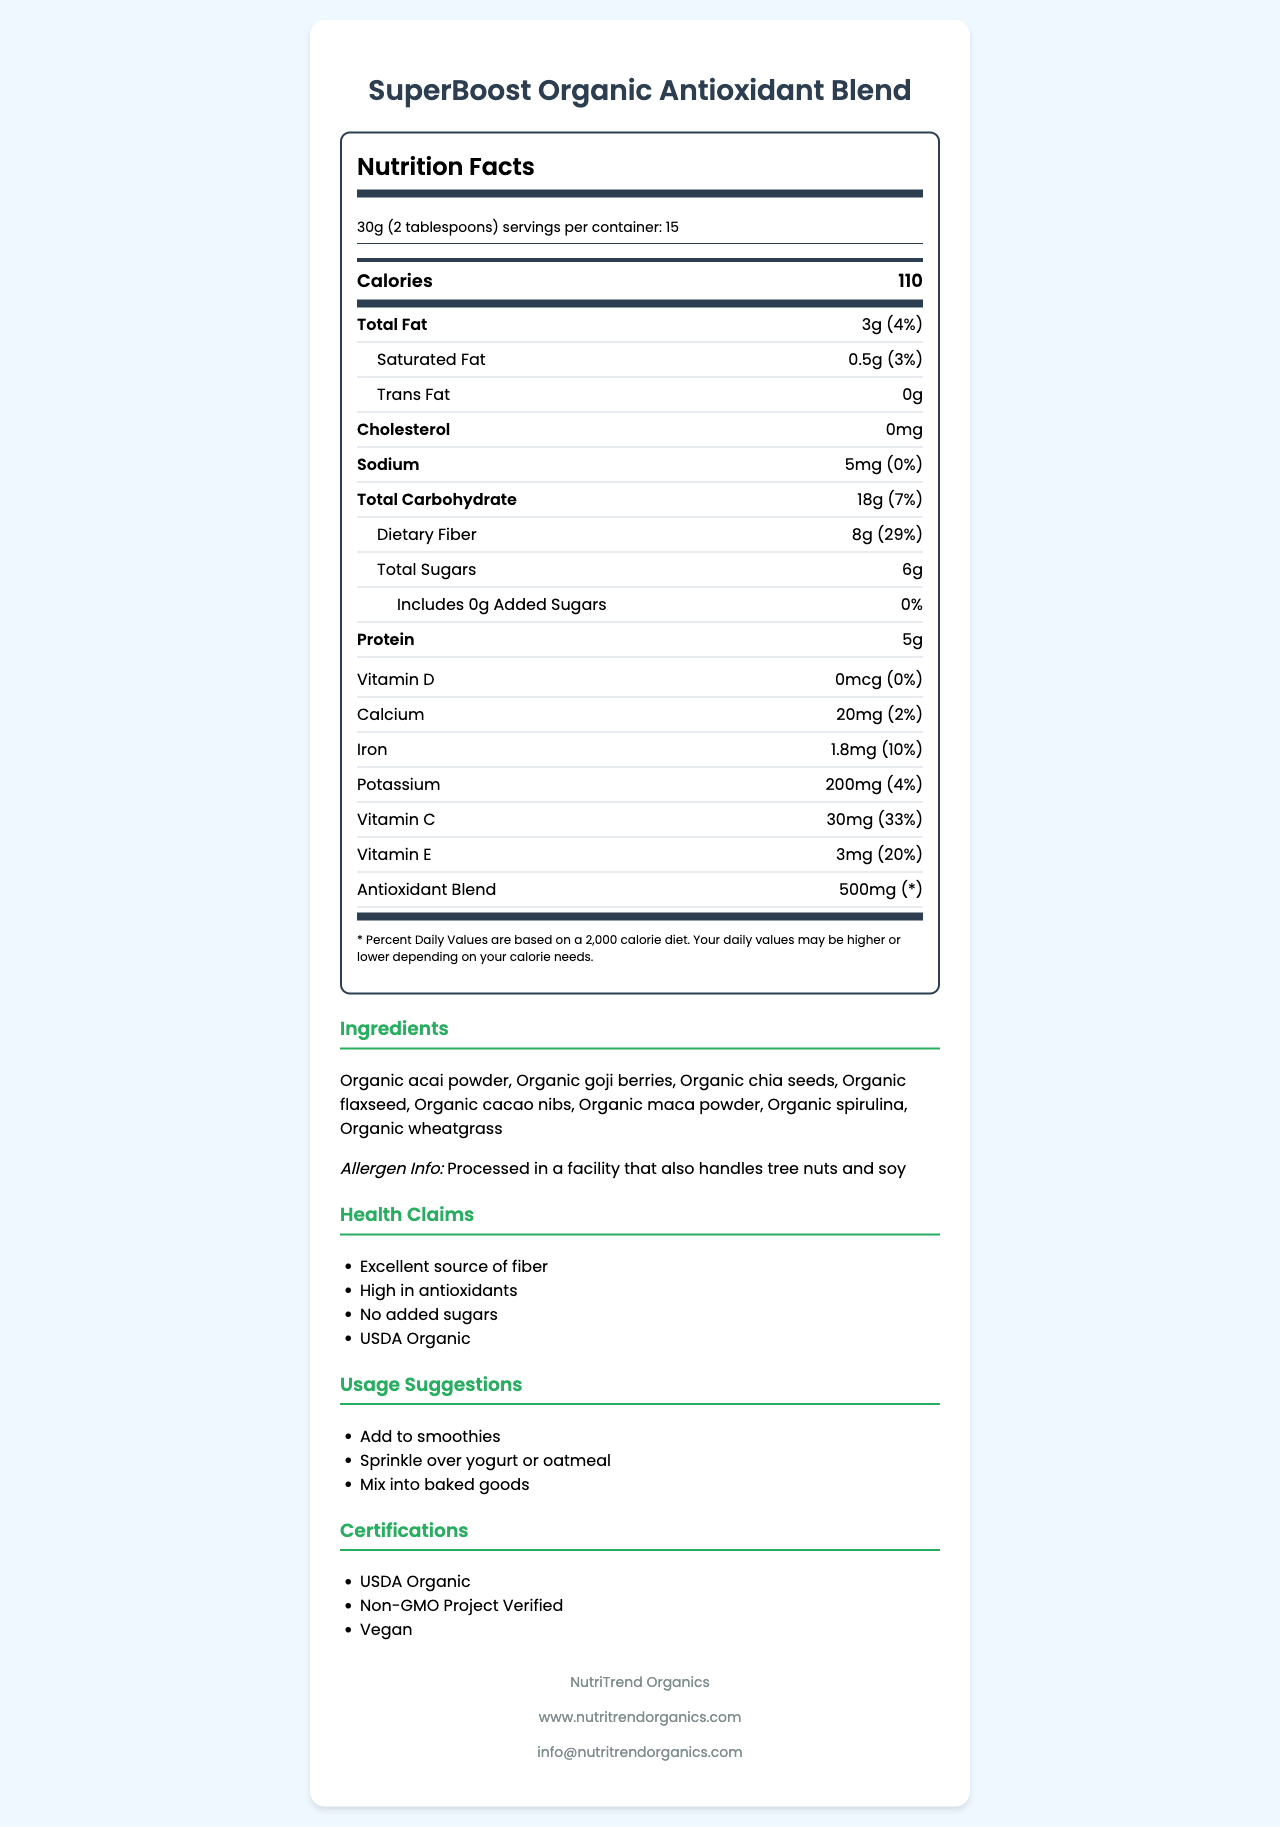what is the serving size? The document specifies the serving size right at the top under "serving info."
Answer: 30g (2 tablespoons) how many calories are in a serving? The document lists the calories as a prominent number in the "large-nutrients" section.
Answer: 110 how much dietary fiber does one serving contain? The amount is listed under "Total Carbohydrate" with an indented label "Dietary Fiber."
Answer: 8g what are the ingredients in this product? The "Ingredients" section lists all the components used in the product.
Answer: Organic acai powder, Organic goji berries, Organic chia seeds, Organic flaxseed, Organic cacao nibs, Organic maca powder, Organic spirulina, Organic wheatgrass how much protein is in one serving? The document lists protein in a dedicated row under the large nutrients.
Answer: 5g what is the suggested storage condition for this product? The "storage instructions" section provides the details for storing the product.
Answer: Store in a cool, dry place. Refrigerate after opening. what is the percentage of daily value for vitamin C? The percentage for vitamin C is listed in the "Vitamins" section of the document.
Answer: 33% how many servings are in one container? The "serving info" section states that there are 15 servings per container.
Answer: 15 what is the cholesterol content per serving? The document shows cholesterol content as 0mg under its own row.
Answer: 0mg does this product contain any added sugars? The document explicitly states "Includes 0g Added Sugars" with a daily value of 0%.
Answer: No which of the following is not an ingredient in this product? A. Organic acai powder B. Organic goji berries C. Organic honey D. Organic spirulina The ingredient list does not mention Organic honey, thus making C the correct answer.
Answer: C what health claim is associated with this product? A. Low in sodium B. High in antioxidants C. Contains caffeine D. Low in calories The health claims section specifically mentions "High in antioxidants."
Answer: B is this product suitable for vegans? The document mentions that this product is "Vegan" in the certifications.
Answer: Yes does this product have any allergens? The document contains a notice saying "Processed in a facility that also handles tree nuts and soy."
Answer: Yes what is the main idea of this document? The document is designed to inform consumers about the nutritional content and usage of the SuperBoost product, emphasizing its health benefits and certifications.
Answer: The document provides detailed nutritional information, ingredients, health claims, certifications, and usage suggestions for SuperBoost Organic Antioxidant Blend, an organic superfood product. where is this product manufactured? The document does not provide details about the product's manufacturing location.
Answer: Not enough information what are the usage suggestions for this product? The "usage suggestions" section lists several ways to use the product.
Answer: Add to smoothies, Sprinkle over yogurt or oatmeal, Mix into baked goods 